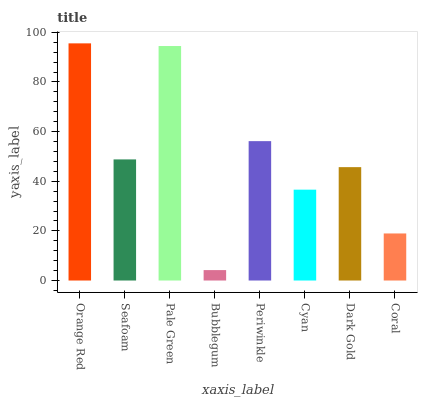Is Bubblegum the minimum?
Answer yes or no. Yes. Is Orange Red the maximum?
Answer yes or no. Yes. Is Seafoam the minimum?
Answer yes or no. No. Is Seafoam the maximum?
Answer yes or no. No. Is Orange Red greater than Seafoam?
Answer yes or no. Yes. Is Seafoam less than Orange Red?
Answer yes or no. Yes. Is Seafoam greater than Orange Red?
Answer yes or no. No. Is Orange Red less than Seafoam?
Answer yes or no. No. Is Seafoam the high median?
Answer yes or no. Yes. Is Dark Gold the low median?
Answer yes or no. Yes. Is Pale Green the high median?
Answer yes or no. No. Is Cyan the low median?
Answer yes or no. No. 